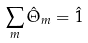<formula> <loc_0><loc_0><loc_500><loc_500>\sum _ { m } \hat { \Theta } _ { m } = \hat { 1 }</formula> 